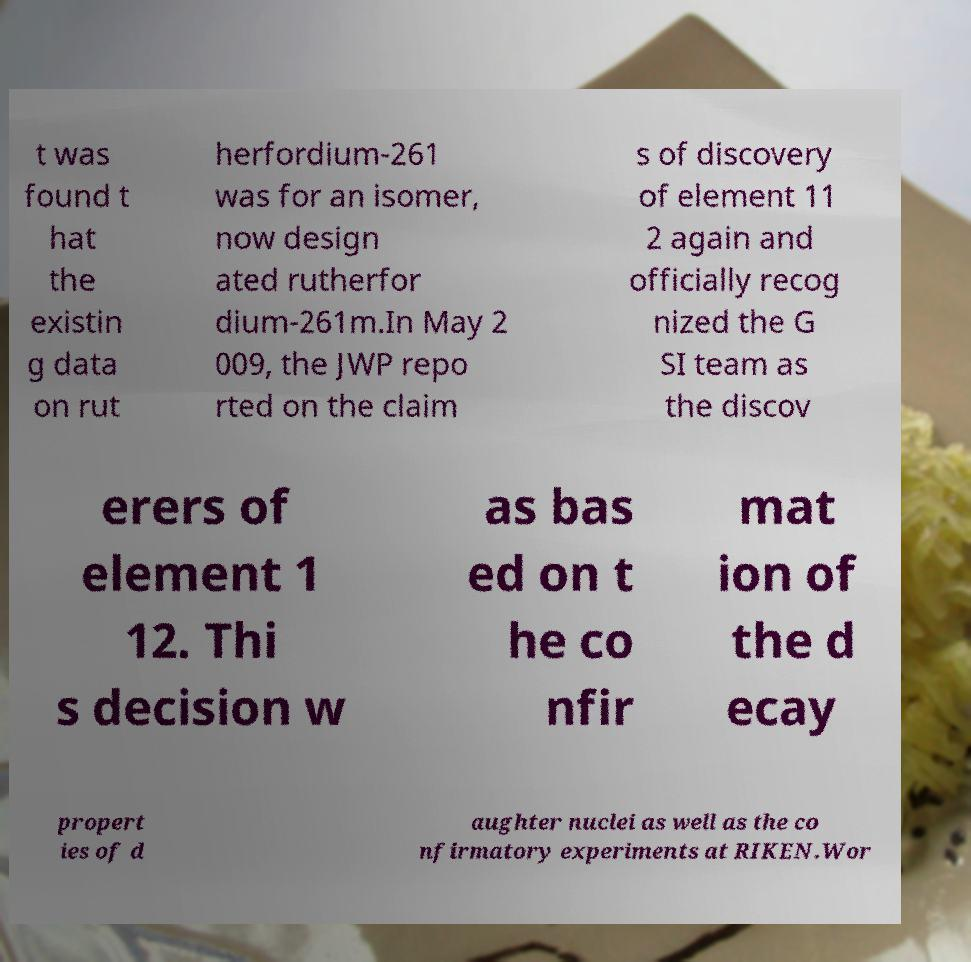Could you assist in decoding the text presented in this image and type it out clearly? t was found t hat the existin g data on rut herfordium-261 was for an isomer, now design ated rutherfor dium-261m.In May 2 009, the JWP repo rted on the claim s of discovery of element 11 2 again and officially recog nized the G SI team as the discov erers of element 1 12. Thi s decision w as bas ed on t he co nfir mat ion of the d ecay propert ies of d aughter nuclei as well as the co nfirmatory experiments at RIKEN.Wor 